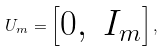Convert formula to latex. <formula><loc_0><loc_0><loc_500><loc_500>U _ { m } = \left [ \begin{matrix} 0 , & I _ { m } \end{matrix} \right ] ,</formula> 